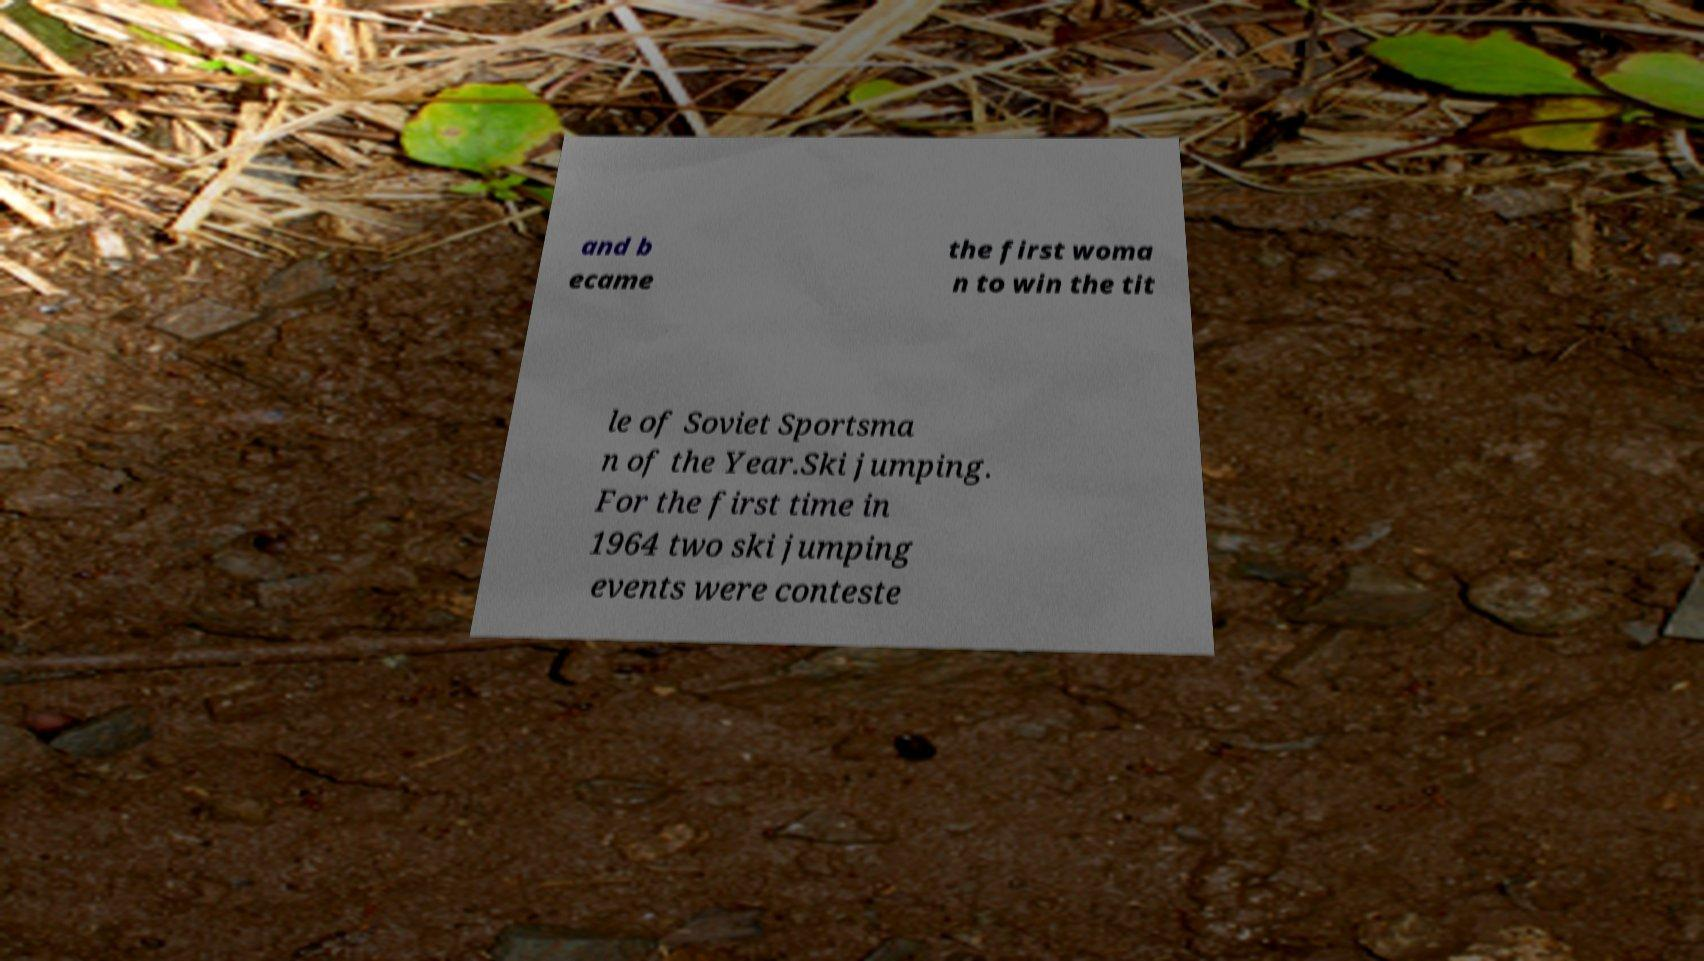What messages or text are displayed in this image? I need them in a readable, typed format. and b ecame the first woma n to win the tit le of Soviet Sportsma n of the Year.Ski jumping. For the first time in 1964 two ski jumping events were conteste 